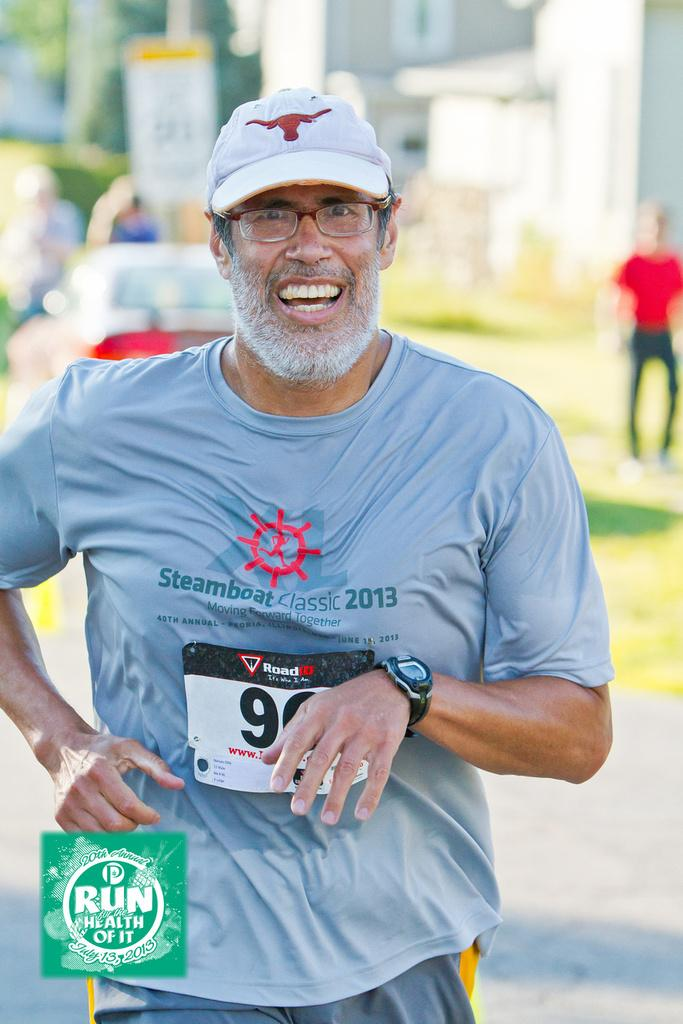What is the main subject of the image? There is a person in the image. What is the person wearing? The person is wearing a cap. What is the person doing in the image? The person is running. Are there any other people visible in the image? Yes, there are other persons visible in the image. What type of natural elements can be seen in the image? There are trees in the image. What type of man-made structures can be seen in the image? There are buildings and pillars in the image. What other object can be seen in the image? There is a board in the image. What type of popcorn is being served on the board in the image? There is no popcorn present in the image; it only features a person running, other people, trees, buildings, pillars, and a board. 